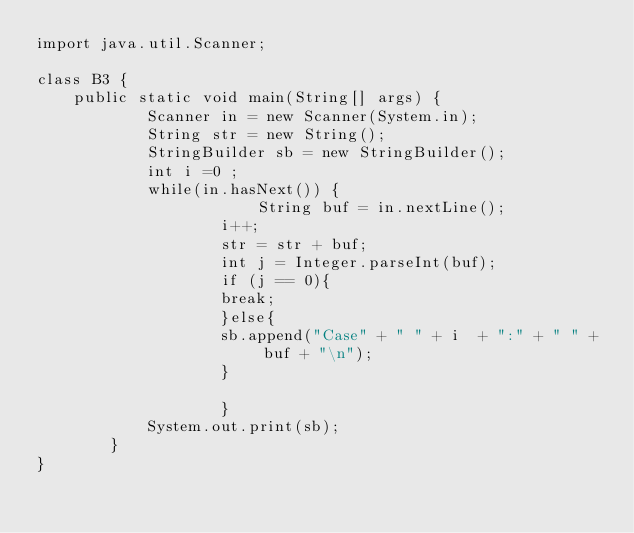Convert code to text. <code><loc_0><loc_0><loc_500><loc_500><_Java_>import java.util.Scanner;                                                               
 
class B3 {
    public static void main(String[] args) {
            Scanner in = new Scanner(System.in);
            String str = new String();
            StringBuilder sb = new StringBuilder();
            int i =0 ;
            while(in.hasNext()) {
                        String buf = in.nextLine();
                    i++;
                    str = str + buf;
                    int j = Integer.parseInt(buf);
                    if (j == 0){
                    break;
                    }else{
                    sb.append("Case" + " " + i  + ":" + " " +  buf + "\n");
                    }

                    }
            System.out.print(sb);
        }
}</code> 